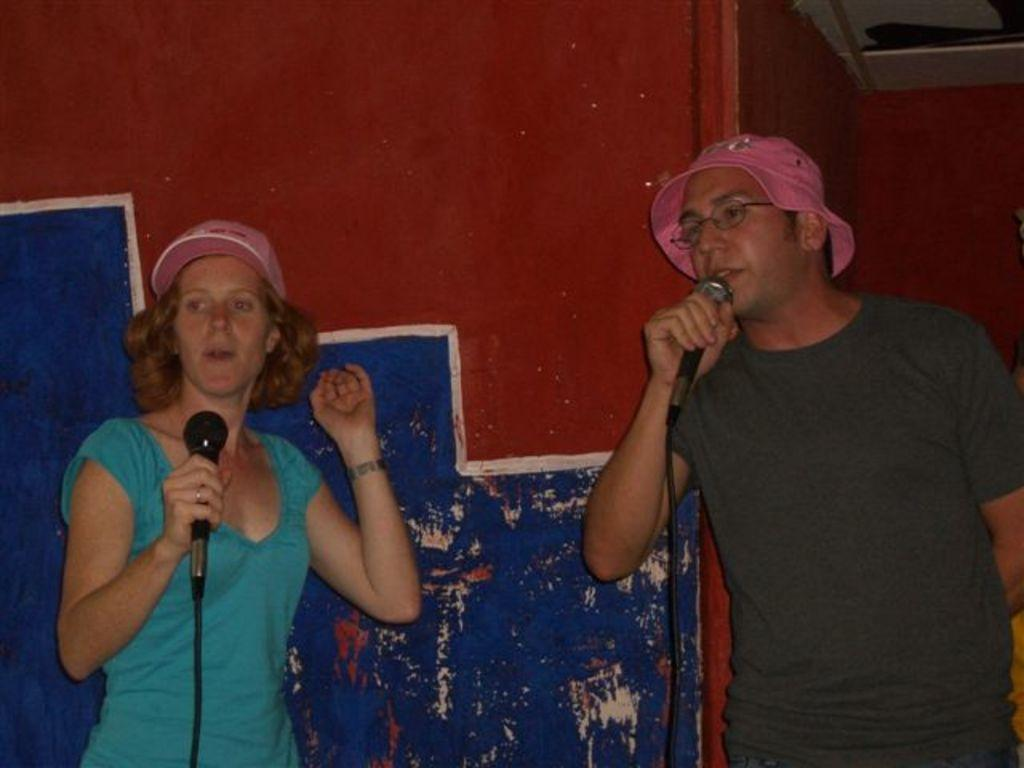What is present in the background of the image? There is a wall in the image. How many people are in the image? There are two people in the image. What are the people wearing on their heads? The two people are wearing hats. What are the people holding in their hands? The two people are holding microphones. What type of bushes can be seen growing on the wall in the image? There are no bushes present on the wall in the image. What idea did the people come up with while holding the microphones? The image does not provide information about any ideas or discussions between the people. 